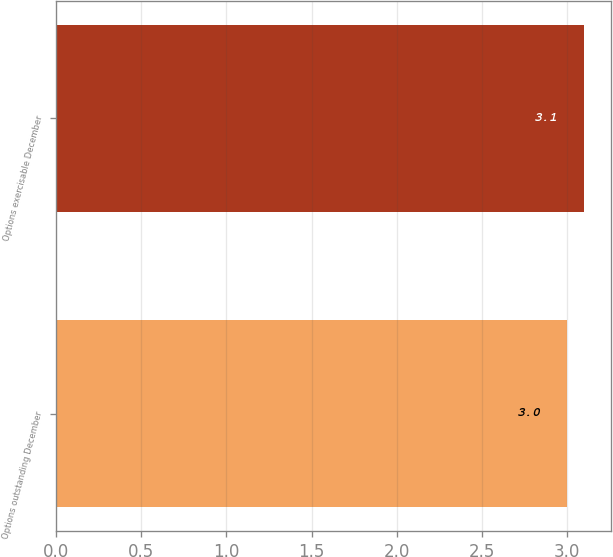<chart> <loc_0><loc_0><loc_500><loc_500><bar_chart><fcel>Options outstanding December<fcel>Options exercisable December<nl><fcel>3<fcel>3.1<nl></chart> 